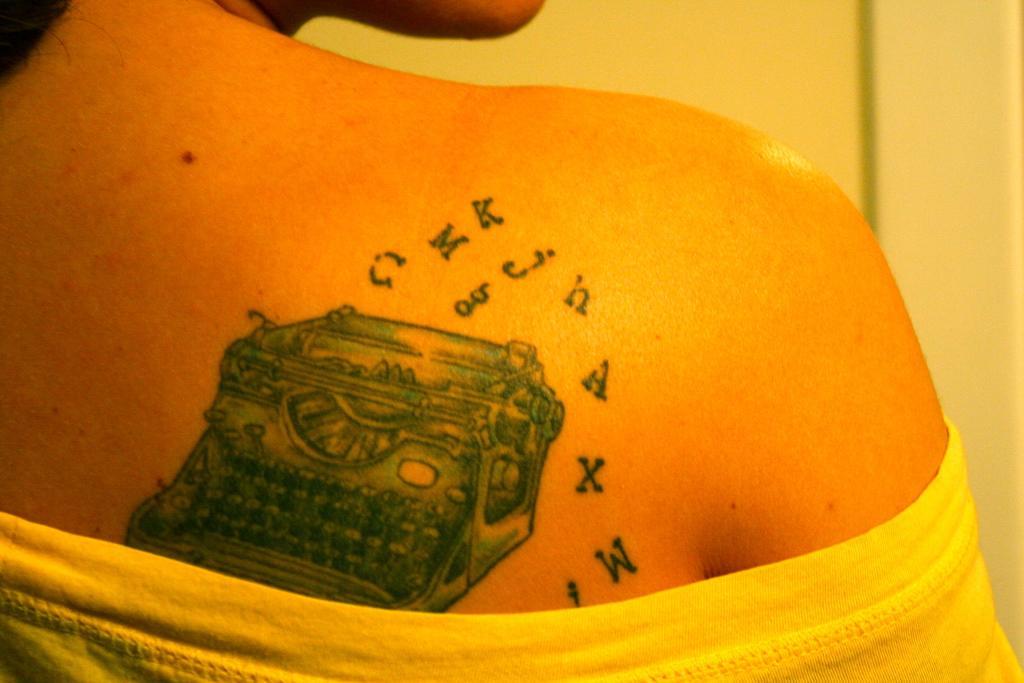Please provide a concise description of this image. In this image, we can see a tattoo on the person and in the background, there is a wall. 